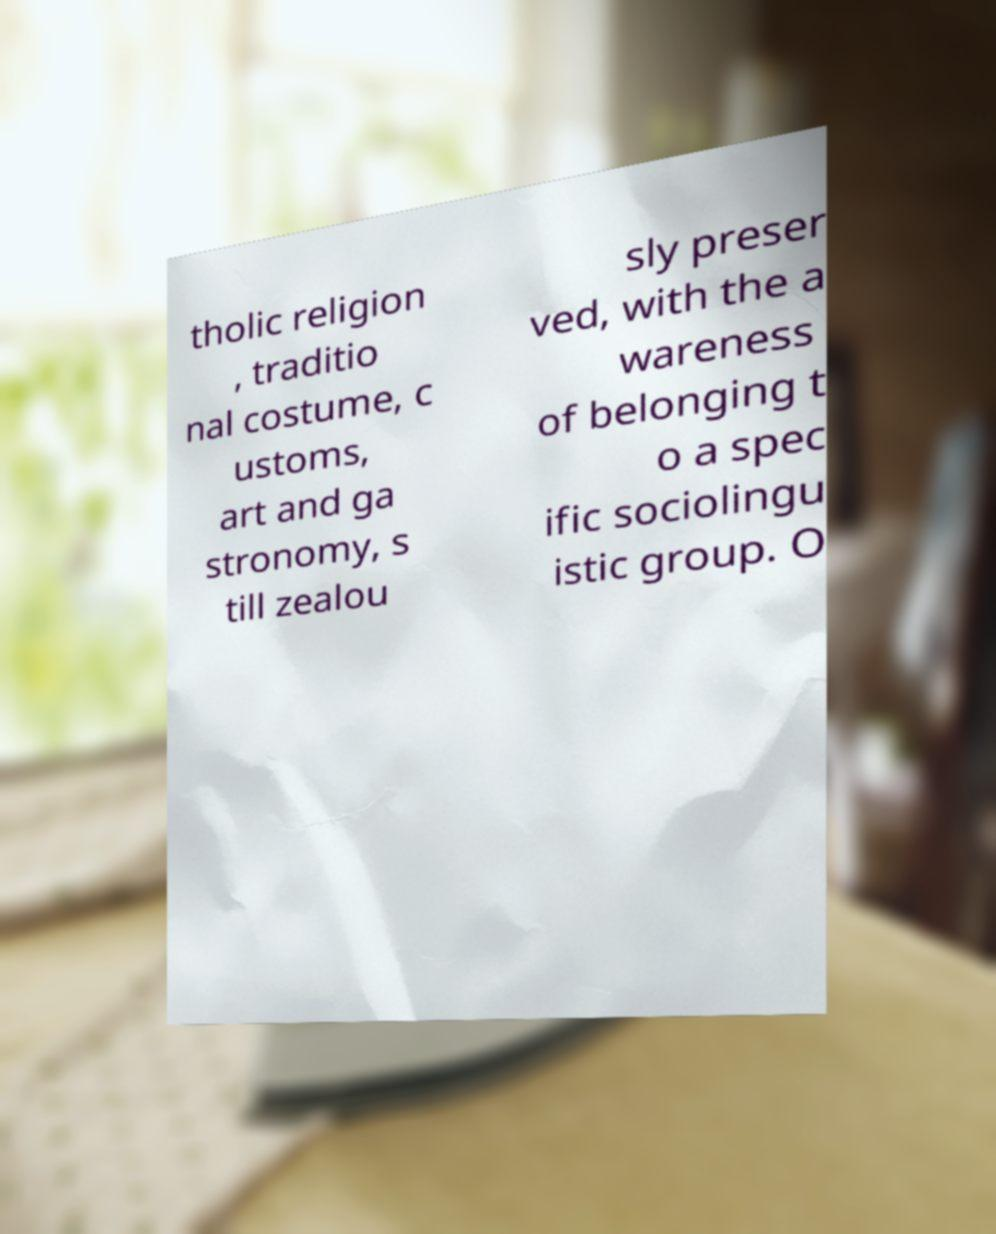Could you extract and type out the text from this image? tholic religion , traditio nal costume, c ustoms, art and ga stronomy, s till zealou sly preser ved, with the a wareness of belonging t o a spec ific sociolingu istic group. O 